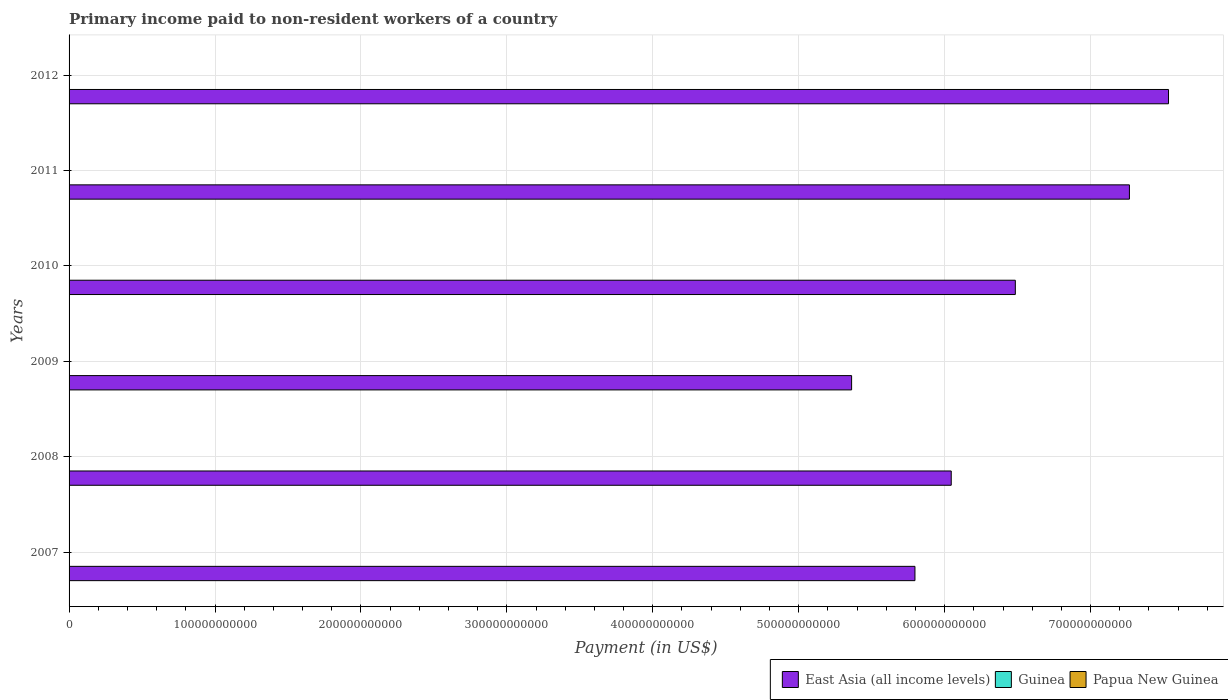Are the number of bars per tick equal to the number of legend labels?
Offer a terse response. Yes. How many bars are there on the 2nd tick from the bottom?
Provide a succinct answer. 3. In how many cases, is the number of bars for a given year not equal to the number of legend labels?
Your answer should be very brief. 0. What is the amount paid to workers in East Asia (all income levels) in 2012?
Keep it short and to the point. 7.53e+11. Across all years, what is the maximum amount paid to workers in Papua New Guinea?
Provide a succinct answer. 1.04e+08. Across all years, what is the minimum amount paid to workers in Papua New Guinea?
Provide a succinct answer. 4.00e+07. In which year was the amount paid to workers in Papua New Guinea maximum?
Offer a terse response. 2007. In which year was the amount paid to workers in East Asia (all income levels) minimum?
Provide a short and direct response. 2009. What is the total amount paid to workers in East Asia (all income levels) in the graph?
Your response must be concise. 3.85e+12. What is the difference between the amount paid to workers in East Asia (all income levels) in 2009 and that in 2011?
Keep it short and to the point. -1.90e+11. What is the difference between the amount paid to workers in Papua New Guinea in 2010 and the amount paid to workers in Guinea in 2008?
Ensure brevity in your answer.  3.17e+07. What is the average amount paid to workers in Guinea per year?
Offer a terse response. 2.70e+07. In the year 2008, what is the difference between the amount paid to workers in East Asia (all income levels) and amount paid to workers in Papua New Guinea?
Give a very brief answer. 6.04e+11. What is the ratio of the amount paid to workers in East Asia (all income levels) in 2010 to that in 2011?
Ensure brevity in your answer.  0.89. Is the amount paid to workers in East Asia (all income levels) in 2010 less than that in 2011?
Your answer should be compact. Yes. Is the difference between the amount paid to workers in East Asia (all income levels) in 2011 and 2012 greater than the difference between the amount paid to workers in Papua New Guinea in 2011 and 2012?
Give a very brief answer. No. What is the difference between the highest and the second highest amount paid to workers in Papua New Guinea?
Keep it short and to the point. 1.92e+07. What is the difference between the highest and the lowest amount paid to workers in Papua New Guinea?
Offer a terse response. 6.44e+07. What does the 3rd bar from the top in 2012 represents?
Provide a short and direct response. East Asia (all income levels). What does the 3rd bar from the bottom in 2012 represents?
Provide a short and direct response. Papua New Guinea. Is it the case that in every year, the sum of the amount paid to workers in Guinea and amount paid to workers in Papua New Guinea is greater than the amount paid to workers in East Asia (all income levels)?
Keep it short and to the point. No. How many bars are there?
Your answer should be compact. 18. Are all the bars in the graph horizontal?
Keep it short and to the point. Yes. What is the difference between two consecutive major ticks on the X-axis?
Provide a short and direct response. 1.00e+11. Does the graph contain grids?
Keep it short and to the point. Yes. Where does the legend appear in the graph?
Offer a terse response. Bottom right. How many legend labels are there?
Your answer should be very brief. 3. How are the legend labels stacked?
Give a very brief answer. Horizontal. What is the title of the graph?
Your answer should be very brief. Primary income paid to non-resident workers of a country. What is the label or title of the X-axis?
Offer a very short reply. Payment (in US$). What is the label or title of the Y-axis?
Give a very brief answer. Years. What is the Payment (in US$) of East Asia (all income levels) in 2007?
Offer a very short reply. 5.80e+11. What is the Payment (in US$) in Guinea in 2007?
Keep it short and to the point. 6.10e+07. What is the Payment (in US$) in Papua New Guinea in 2007?
Keep it short and to the point. 1.04e+08. What is the Payment (in US$) in East Asia (all income levels) in 2008?
Your answer should be very brief. 6.05e+11. What is the Payment (in US$) in Guinea in 2008?
Make the answer very short. 9.85e+06. What is the Payment (in US$) of Papua New Guinea in 2008?
Your answer should be compact. 8.51e+07. What is the Payment (in US$) in East Asia (all income levels) in 2009?
Ensure brevity in your answer.  5.36e+11. What is the Payment (in US$) in Guinea in 2009?
Your answer should be compact. 2.22e+07. What is the Payment (in US$) of Papua New Guinea in 2009?
Your answer should be compact. 4.63e+07. What is the Payment (in US$) in East Asia (all income levels) in 2010?
Keep it short and to the point. 6.48e+11. What is the Payment (in US$) in Guinea in 2010?
Make the answer very short. 1.49e+07. What is the Payment (in US$) of Papua New Guinea in 2010?
Make the answer very short. 4.16e+07. What is the Payment (in US$) in East Asia (all income levels) in 2011?
Keep it short and to the point. 7.27e+11. What is the Payment (in US$) in Guinea in 2011?
Your response must be concise. 2.22e+07. What is the Payment (in US$) of Papua New Guinea in 2011?
Provide a succinct answer. 4.00e+07. What is the Payment (in US$) of East Asia (all income levels) in 2012?
Your answer should be very brief. 7.53e+11. What is the Payment (in US$) of Guinea in 2012?
Make the answer very short. 3.15e+07. What is the Payment (in US$) of Papua New Guinea in 2012?
Offer a very short reply. 4.49e+07. Across all years, what is the maximum Payment (in US$) of East Asia (all income levels)?
Your answer should be compact. 7.53e+11. Across all years, what is the maximum Payment (in US$) in Guinea?
Ensure brevity in your answer.  6.10e+07. Across all years, what is the maximum Payment (in US$) of Papua New Guinea?
Provide a short and direct response. 1.04e+08. Across all years, what is the minimum Payment (in US$) of East Asia (all income levels)?
Give a very brief answer. 5.36e+11. Across all years, what is the minimum Payment (in US$) in Guinea?
Provide a short and direct response. 9.85e+06. Across all years, what is the minimum Payment (in US$) of Papua New Guinea?
Give a very brief answer. 4.00e+07. What is the total Payment (in US$) of East Asia (all income levels) in the graph?
Make the answer very short. 3.85e+12. What is the total Payment (in US$) of Guinea in the graph?
Your answer should be compact. 1.62e+08. What is the total Payment (in US$) of Papua New Guinea in the graph?
Make the answer very short. 3.62e+08. What is the difference between the Payment (in US$) in East Asia (all income levels) in 2007 and that in 2008?
Make the answer very short. -2.49e+1. What is the difference between the Payment (in US$) of Guinea in 2007 and that in 2008?
Offer a very short reply. 5.11e+07. What is the difference between the Payment (in US$) of Papua New Guinea in 2007 and that in 2008?
Your answer should be very brief. 1.92e+07. What is the difference between the Payment (in US$) in East Asia (all income levels) in 2007 and that in 2009?
Provide a short and direct response. 4.34e+1. What is the difference between the Payment (in US$) in Guinea in 2007 and that in 2009?
Your answer should be very brief. 3.88e+07. What is the difference between the Payment (in US$) of Papua New Guinea in 2007 and that in 2009?
Keep it short and to the point. 5.80e+07. What is the difference between the Payment (in US$) in East Asia (all income levels) in 2007 and that in 2010?
Ensure brevity in your answer.  -6.88e+1. What is the difference between the Payment (in US$) in Guinea in 2007 and that in 2010?
Your answer should be compact. 4.60e+07. What is the difference between the Payment (in US$) of Papua New Guinea in 2007 and that in 2010?
Offer a terse response. 6.28e+07. What is the difference between the Payment (in US$) in East Asia (all income levels) in 2007 and that in 2011?
Keep it short and to the point. -1.47e+11. What is the difference between the Payment (in US$) in Guinea in 2007 and that in 2011?
Make the answer very short. 3.87e+07. What is the difference between the Payment (in US$) in Papua New Guinea in 2007 and that in 2011?
Keep it short and to the point. 6.44e+07. What is the difference between the Payment (in US$) of East Asia (all income levels) in 2007 and that in 2012?
Your answer should be very brief. -1.74e+11. What is the difference between the Payment (in US$) in Guinea in 2007 and that in 2012?
Offer a very short reply. 2.94e+07. What is the difference between the Payment (in US$) of Papua New Guinea in 2007 and that in 2012?
Your answer should be compact. 5.95e+07. What is the difference between the Payment (in US$) in East Asia (all income levels) in 2008 and that in 2009?
Your response must be concise. 6.83e+1. What is the difference between the Payment (in US$) of Guinea in 2008 and that in 2009?
Keep it short and to the point. -1.23e+07. What is the difference between the Payment (in US$) in Papua New Guinea in 2008 and that in 2009?
Offer a terse response. 3.88e+07. What is the difference between the Payment (in US$) in East Asia (all income levels) in 2008 and that in 2010?
Make the answer very short. -4.39e+1. What is the difference between the Payment (in US$) in Guinea in 2008 and that in 2010?
Keep it short and to the point. -5.08e+06. What is the difference between the Payment (in US$) of Papua New Guinea in 2008 and that in 2010?
Your response must be concise. 4.36e+07. What is the difference between the Payment (in US$) in East Asia (all income levels) in 2008 and that in 2011?
Your answer should be compact. -1.22e+11. What is the difference between the Payment (in US$) in Guinea in 2008 and that in 2011?
Ensure brevity in your answer.  -1.24e+07. What is the difference between the Payment (in US$) in Papua New Guinea in 2008 and that in 2011?
Provide a succinct answer. 4.52e+07. What is the difference between the Payment (in US$) in East Asia (all income levels) in 2008 and that in 2012?
Provide a succinct answer. -1.49e+11. What is the difference between the Payment (in US$) of Guinea in 2008 and that in 2012?
Your answer should be compact. -2.17e+07. What is the difference between the Payment (in US$) in Papua New Guinea in 2008 and that in 2012?
Keep it short and to the point. 4.02e+07. What is the difference between the Payment (in US$) of East Asia (all income levels) in 2009 and that in 2010?
Provide a succinct answer. -1.12e+11. What is the difference between the Payment (in US$) of Guinea in 2009 and that in 2010?
Give a very brief answer. 7.24e+06. What is the difference between the Payment (in US$) of Papua New Guinea in 2009 and that in 2010?
Your answer should be compact. 4.76e+06. What is the difference between the Payment (in US$) in East Asia (all income levels) in 2009 and that in 2011?
Your response must be concise. -1.90e+11. What is the difference between the Payment (in US$) of Guinea in 2009 and that in 2011?
Keep it short and to the point. -7.00e+04. What is the difference between the Payment (in US$) of Papua New Guinea in 2009 and that in 2011?
Keep it short and to the point. 6.37e+06. What is the difference between the Payment (in US$) of East Asia (all income levels) in 2009 and that in 2012?
Provide a succinct answer. -2.17e+11. What is the difference between the Payment (in US$) of Guinea in 2009 and that in 2012?
Keep it short and to the point. -9.37e+06. What is the difference between the Payment (in US$) of Papua New Guinea in 2009 and that in 2012?
Provide a succinct answer. 1.43e+06. What is the difference between the Payment (in US$) of East Asia (all income levels) in 2010 and that in 2011?
Offer a terse response. -7.82e+1. What is the difference between the Payment (in US$) of Guinea in 2010 and that in 2011?
Your response must be concise. -7.31e+06. What is the difference between the Payment (in US$) of Papua New Guinea in 2010 and that in 2011?
Provide a short and direct response. 1.61e+06. What is the difference between the Payment (in US$) in East Asia (all income levels) in 2010 and that in 2012?
Your answer should be very brief. -1.05e+11. What is the difference between the Payment (in US$) in Guinea in 2010 and that in 2012?
Your answer should be very brief. -1.66e+07. What is the difference between the Payment (in US$) in Papua New Guinea in 2010 and that in 2012?
Give a very brief answer. -3.33e+06. What is the difference between the Payment (in US$) in East Asia (all income levels) in 2011 and that in 2012?
Offer a very short reply. -2.68e+1. What is the difference between the Payment (in US$) of Guinea in 2011 and that in 2012?
Ensure brevity in your answer.  -9.30e+06. What is the difference between the Payment (in US$) in Papua New Guinea in 2011 and that in 2012?
Your answer should be very brief. -4.94e+06. What is the difference between the Payment (in US$) in East Asia (all income levels) in 2007 and the Payment (in US$) in Guinea in 2008?
Give a very brief answer. 5.80e+11. What is the difference between the Payment (in US$) in East Asia (all income levels) in 2007 and the Payment (in US$) in Papua New Guinea in 2008?
Your answer should be compact. 5.80e+11. What is the difference between the Payment (in US$) in Guinea in 2007 and the Payment (in US$) in Papua New Guinea in 2008?
Provide a succinct answer. -2.42e+07. What is the difference between the Payment (in US$) of East Asia (all income levels) in 2007 and the Payment (in US$) of Guinea in 2009?
Give a very brief answer. 5.80e+11. What is the difference between the Payment (in US$) in East Asia (all income levels) in 2007 and the Payment (in US$) in Papua New Guinea in 2009?
Your answer should be compact. 5.80e+11. What is the difference between the Payment (in US$) in Guinea in 2007 and the Payment (in US$) in Papua New Guinea in 2009?
Keep it short and to the point. 1.46e+07. What is the difference between the Payment (in US$) in East Asia (all income levels) in 2007 and the Payment (in US$) in Guinea in 2010?
Your answer should be compact. 5.80e+11. What is the difference between the Payment (in US$) in East Asia (all income levels) in 2007 and the Payment (in US$) in Papua New Guinea in 2010?
Offer a very short reply. 5.80e+11. What is the difference between the Payment (in US$) in Guinea in 2007 and the Payment (in US$) in Papua New Guinea in 2010?
Keep it short and to the point. 1.94e+07. What is the difference between the Payment (in US$) in East Asia (all income levels) in 2007 and the Payment (in US$) in Guinea in 2011?
Your answer should be compact. 5.80e+11. What is the difference between the Payment (in US$) in East Asia (all income levels) in 2007 and the Payment (in US$) in Papua New Guinea in 2011?
Ensure brevity in your answer.  5.80e+11. What is the difference between the Payment (in US$) in Guinea in 2007 and the Payment (in US$) in Papua New Guinea in 2011?
Offer a terse response. 2.10e+07. What is the difference between the Payment (in US$) of East Asia (all income levels) in 2007 and the Payment (in US$) of Guinea in 2012?
Ensure brevity in your answer.  5.80e+11. What is the difference between the Payment (in US$) of East Asia (all income levels) in 2007 and the Payment (in US$) of Papua New Guinea in 2012?
Offer a terse response. 5.80e+11. What is the difference between the Payment (in US$) of Guinea in 2007 and the Payment (in US$) of Papua New Guinea in 2012?
Give a very brief answer. 1.61e+07. What is the difference between the Payment (in US$) of East Asia (all income levels) in 2008 and the Payment (in US$) of Guinea in 2009?
Give a very brief answer. 6.04e+11. What is the difference between the Payment (in US$) in East Asia (all income levels) in 2008 and the Payment (in US$) in Papua New Guinea in 2009?
Provide a short and direct response. 6.04e+11. What is the difference between the Payment (in US$) of Guinea in 2008 and the Payment (in US$) of Papua New Guinea in 2009?
Your answer should be very brief. -3.65e+07. What is the difference between the Payment (in US$) in East Asia (all income levels) in 2008 and the Payment (in US$) in Guinea in 2010?
Keep it short and to the point. 6.05e+11. What is the difference between the Payment (in US$) of East Asia (all income levels) in 2008 and the Payment (in US$) of Papua New Guinea in 2010?
Your answer should be very brief. 6.04e+11. What is the difference between the Payment (in US$) of Guinea in 2008 and the Payment (in US$) of Papua New Guinea in 2010?
Make the answer very short. -3.17e+07. What is the difference between the Payment (in US$) in East Asia (all income levels) in 2008 and the Payment (in US$) in Guinea in 2011?
Your answer should be compact. 6.04e+11. What is the difference between the Payment (in US$) in East Asia (all income levels) in 2008 and the Payment (in US$) in Papua New Guinea in 2011?
Keep it short and to the point. 6.04e+11. What is the difference between the Payment (in US$) of Guinea in 2008 and the Payment (in US$) of Papua New Guinea in 2011?
Provide a succinct answer. -3.01e+07. What is the difference between the Payment (in US$) of East Asia (all income levels) in 2008 and the Payment (in US$) of Guinea in 2012?
Offer a very short reply. 6.04e+11. What is the difference between the Payment (in US$) in East Asia (all income levels) in 2008 and the Payment (in US$) in Papua New Guinea in 2012?
Provide a succinct answer. 6.04e+11. What is the difference between the Payment (in US$) of Guinea in 2008 and the Payment (in US$) of Papua New Guinea in 2012?
Give a very brief answer. -3.51e+07. What is the difference between the Payment (in US$) of East Asia (all income levels) in 2009 and the Payment (in US$) of Guinea in 2010?
Give a very brief answer. 5.36e+11. What is the difference between the Payment (in US$) in East Asia (all income levels) in 2009 and the Payment (in US$) in Papua New Guinea in 2010?
Keep it short and to the point. 5.36e+11. What is the difference between the Payment (in US$) of Guinea in 2009 and the Payment (in US$) of Papua New Guinea in 2010?
Give a very brief answer. -1.94e+07. What is the difference between the Payment (in US$) of East Asia (all income levels) in 2009 and the Payment (in US$) of Guinea in 2011?
Provide a succinct answer. 5.36e+11. What is the difference between the Payment (in US$) of East Asia (all income levels) in 2009 and the Payment (in US$) of Papua New Guinea in 2011?
Ensure brevity in your answer.  5.36e+11. What is the difference between the Payment (in US$) in Guinea in 2009 and the Payment (in US$) in Papua New Guinea in 2011?
Provide a short and direct response. -1.78e+07. What is the difference between the Payment (in US$) in East Asia (all income levels) in 2009 and the Payment (in US$) in Guinea in 2012?
Keep it short and to the point. 5.36e+11. What is the difference between the Payment (in US$) in East Asia (all income levels) in 2009 and the Payment (in US$) in Papua New Guinea in 2012?
Your answer should be very brief. 5.36e+11. What is the difference between the Payment (in US$) of Guinea in 2009 and the Payment (in US$) of Papua New Guinea in 2012?
Provide a short and direct response. -2.28e+07. What is the difference between the Payment (in US$) of East Asia (all income levels) in 2010 and the Payment (in US$) of Guinea in 2011?
Ensure brevity in your answer.  6.48e+11. What is the difference between the Payment (in US$) of East Asia (all income levels) in 2010 and the Payment (in US$) of Papua New Guinea in 2011?
Offer a terse response. 6.48e+11. What is the difference between the Payment (in US$) in Guinea in 2010 and the Payment (in US$) in Papua New Guinea in 2011?
Ensure brevity in your answer.  -2.51e+07. What is the difference between the Payment (in US$) of East Asia (all income levels) in 2010 and the Payment (in US$) of Guinea in 2012?
Your answer should be compact. 6.48e+11. What is the difference between the Payment (in US$) in East Asia (all income levels) in 2010 and the Payment (in US$) in Papua New Guinea in 2012?
Offer a terse response. 6.48e+11. What is the difference between the Payment (in US$) in Guinea in 2010 and the Payment (in US$) in Papua New Guinea in 2012?
Provide a short and direct response. -3.00e+07. What is the difference between the Payment (in US$) in East Asia (all income levels) in 2011 and the Payment (in US$) in Guinea in 2012?
Provide a short and direct response. 7.27e+11. What is the difference between the Payment (in US$) of East Asia (all income levels) in 2011 and the Payment (in US$) of Papua New Guinea in 2012?
Your answer should be very brief. 7.27e+11. What is the difference between the Payment (in US$) in Guinea in 2011 and the Payment (in US$) in Papua New Guinea in 2012?
Provide a short and direct response. -2.27e+07. What is the average Payment (in US$) of East Asia (all income levels) per year?
Give a very brief answer. 6.41e+11. What is the average Payment (in US$) of Guinea per year?
Provide a short and direct response. 2.70e+07. What is the average Payment (in US$) in Papua New Guinea per year?
Make the answer very short. 6.04e+07. In the year 2007, what is the difference between the Payment (in US$) of East Asia (all income levels) and Payment (in US$) of Guinea?
Your answer should be compact. 5.80e+11. In the year 2007, what is the difference between the Payment (in US$) in East Asia (all income levels) and Payment (in US$) in Papua New Guinea?
Your response must be concise. 5.80e+11. In the year 2007, what is the difference between the Payment (in US$) of Guinea and Payment (in US$) of Papua New Guinea?
Make the answer very short. -4.34e+07. In the year 2008, what is the difference between the Payment (in US$) in East Asia (all income levels) and Payment (in US$) in Guinea?
Ensure brevity in your answer.  6.05e+11. In the year 2008, what is the difference between the Payment (in US$) in East Asia (all income levels) and Payment (in US$) in Papua New Guinea?
Your answer should be very brief. 6.04e+11. In the year 2008, what is the difference between the Payment (in US$) of Guinea and Payment (in US$) of Papua New Guinea?
Give a very brief answer. -7.53e+07. In the year 2009, what is the difference between the Payment (in US$) in East Asia (all income levels) and Payment (in US$) in Guinea?
Provide a succinct answer. 5.36e+11. In the year 2009, what is the difference between the Payment (in US$) of East Asia (all income levels) and Payment (in US$) of Papua New Guinea?
Keep it short and to the point. 5.36e+11. In the year 2009, what is the difference between the Payment (in US$) of Guinea and Payment (in US$) of Papua New Guinea?
Offer a terse response. -2.42e+07. In the year 2010, what is the difference between the Payment (in US$) of East Asia (all income levels) and Payment (in US$) of Guinea?
Offer a very short reply. 6.48e+11. In the year 2010, what is the difference between the Payment (in US$) of East Asia (all income levels) and Payment (in US$) of Papua New Guinea?
Your answer should be very brief. 6.48e+11. In the year 2010, what is the difference between the Payment (in US$) in Guinea and Payment (in US$) in Papua New Guinea?
Give a very brief answer. -2.67e+07. In the year 2011, what is the difference between the Payment (in US$) of East Asia (all income levels) and Payment (in US$) of Guinea?
Your response must be concise. 7.27e+11. In the year 2011, what is the difference between the Payment (in US$) of East Asia (all income levels) and Payment (in US$) of Papua New Guinea?
Offer a very short reply. 7.27e+11. In the year 2011, what is the difference between the Payment (in US$) in Guinea and Payment (in US$) in Papua New Guinea?
Offer a terse response. -1.77e+07. In the year 2012, what is the difference between the Payment (in US$) in East Asia (all income levels) and Payment (in US$) in Guinea?
Provide a short and direct response. 7.53e+11. In the year 2012, what is the difference between the Payment (in US$) of East Asia (all income levels) and Payment (in US$) of Papua New Guinea?
Make the answer very short. 7.53e+11. In the year 2012, what is the difference between the Payment (in US$) in Guinea and Payment (in US$) in Papua New Guinea?
Offer a very short reply. -1.34e+07. What is the ratio of the Payment (in US$) of East Asia (all income levels) in 2007 to that in 2008?
Your answer should be very brief. 0.96. What is the ratio of the Payment (in US$) in Guinea in 2007 to that in 2008?
Make the answer very short. 6.19. What is the ratio of the Payment (in US$) of Papua New Guinea in 2007 to that in 2008?
Provide a succinct answer. 1.23. What is the ratio of the Payment (in US$) of East Asia (all income levels) in 2007 to that in 2009?
Ensure brevity in your answer.  1.08. What is the ratio of the Payment (in US$) in Guinea in 2007 to that in 2009?
Give a very brief answer. 2.75. What is the ratio of the Payment (in US$) of Papua New Guinea in 2007 to that in 2009?
Offer a very short reply. 2.25. What is the ratio of the Payment (in US$) of East Asia (all income levels) in 2007 to that in 2010?
Make the answer very short. 0.89. What is the ratio of the Payment (in US$) in Guinea in 2007 to that in 2010?
Your answer should be very brief. 4.08. What is the ratio of the Payment (in US$) in Papua New Guinea in 2007 to that in 2010?
Your answer should be very brief. 2.51. What is the ratio of the Payment (in US$) in East Asia (all income levels) in 2007 to that in 2011?
Ensure brevity in your answer.  0.8. What is the ratio of the Payment (in US$) of Guinea in 2007 to that in 2011?
Offer a very short reply. 2.74. What is the ratio of the Payment (in US$) in Papua New Guinea in 2007 to that in 2011?
Provide a short and direct response. 2.61. What is the ratio of the Payment (in US$) in East Asia (all income levels) in 2007 to that in 2012?
Your answer should be very brief. 0.77. What is the ratio of the Payment (in US$) of Guinea in 2007 to that in 2012?
Provide a short and direct response. 1.93. What is the ratio of the Payment (in US$) of Papua New Guinea in 2007 to that in 2012?
Offer a very short reply. 2.32. What is the ratio of the Payment (in US$) of East Asia (all income levels) in 2008 to that in 2009?
Offer a terse response. 1.13. What is the ratio of the Payment (in US$) of Guinea in 2008 to that in 2009?
Your response must be concise. 0.44. What is the ratio of the Payment (in US$) in Papua New Guinea in 2008 to that in 2009?
Give a very brief answer. 1.84. What is the ratio of the Payment (in US$) of East Asia (all income levels) in 2008 to that in 2010?
Provide a succinct answer. 0.93. What is the ratio of the Payment (in US$) of Guinea in 2008 to that in 2010?
Give a very brief answer. 0.66. What is the ratio of the Payment (in US$) in Papua New Guinea in 2008 to that in 2010?
Offer a very short reply. 2.05. What is the ratio of the Payment (in US$) in East Asia (all income levels) in 2008 to that in 2011?
Make the answer very short. 0.83. What is the ratio of the Payment (in US$) of Guinea in 2008 to that in 2011?
Keep it short and to the point. 0.44. What is the ratio of the Payment (in US$) of Papua New Guinea in 2008 to that in 2011?
Keep it short and to the point. 2.13. What is the ratio of the Payment (in US$) of East Asia (all income levels) in 2008 to that in 2012?
Your answer should be very brief. 0.8. What is the ratio of the Payment (in US$) in Guinea in 2008 to that in 2012?
Your response must be concise. 0.31. What is the ratio of the Payment (in US$) of Papua New Guinea in 2008 to that in 2012?
Make the answer very short. 1.9. What is the ratio of the Payment (in US$) of East Asia (all income levels) in 2009 to that in 2010?
Give a very brief answer. 0.83. What is the ratio of the Payment (in US$) of Guinea in 2009 to that in 2010?
Give a very brief answer. 1.48. What is the ratio of the Payment (in US$) of Papua New Guinea in 2009 to that in 2010?
Provide a succinct answer. 1.11. What is the ratio of the Payment (in US$) in East Asia (all income levels) in 2009 to that in 2011?
Keep it short and to the point. 0.74. What is the ratio of the Payment (in US$) of Papua New Guinea in 2009 to that in 2011?
Offer a terse response. 1.16. What is the ratio of the Payment (in US$) of East Asia (all income levels) in 2009 to that in 2012?
Provide a short and direct response. 0.71. What is the ratio of the Payment (in US$) in Guinea in 2009 to that in 2012?
Keep it short and to the point. 0.7. What is the ratio of the Payment (in US$) in Papua New Guinea in 2009 to that in 2012?
Your answer should be compact. 1.03. What is the ratio of the Payment (in US$) of East Asia (all income levels) in 2010 to that in 2011?
Keep it short and to the point. 0.89. What is the ratio of the Payment (in US$) in Guinea in 2010 to that in 2011?
Make the answer very short. 0.67. What is the ratio of the Payment (in US$) of Papua New Guinea in 2010 to that in 2011?
Provide a succinct answer. 1.04. What is the ratio of the Payment (in US$) of East Asia (all income levels) in 2010 to that in 2012?
Provide a short and direct response. 0.86. What is the ratio of the Payment (in US$) in Guinea in 2010 to that in 2012?
Keep it short and to the point. 0.47. What is the ratio of the Payment (in US$) of Papua New Guinea in 2010 to that in 2012?
Offer a very short reply. 0.93. What is the ratio of the Payment (in US$) of East Asia (all income levels) in 2011 to that in 2012?
Provide a short and direct response. 0.96. What is the ratio of the Payment (in US$) in Guinea in 2011 to that in 2012?
Ensure brevity in your answer.  0.71. What is the ratio of the Payment (in US$) in Papua New Guinea in 2011 to that in 2012?
Provide a succinct answer. 0.89. What is the difference between the highest and the second highest Payment (in US$) in East Asia (all income levels)?
Provide a short and direct response. 2.68e+1. What is the difference between the highest and the second highest Payment (in US$) of Guinea?
Your response must be concise. 2.94e+07. What is the difference between the highest and the second highest Payment (in US$) in Papua New Guinea?
Give a very brief answer. 1.92e+07. What is the difference between the highest and the lowest Payment (in US$) of East Asia (all income levels)?
Your answer should be very brief. 2.17e+11. What is the difference between the highest and the lowest Payment (in US$) of Guinea?
Your answer should be compact. 5.11e+07. What is the difference between the highest and the lowest Payment (in US$) of Papua New Guinea?
Your answer should be compact. 6.44e+07. 